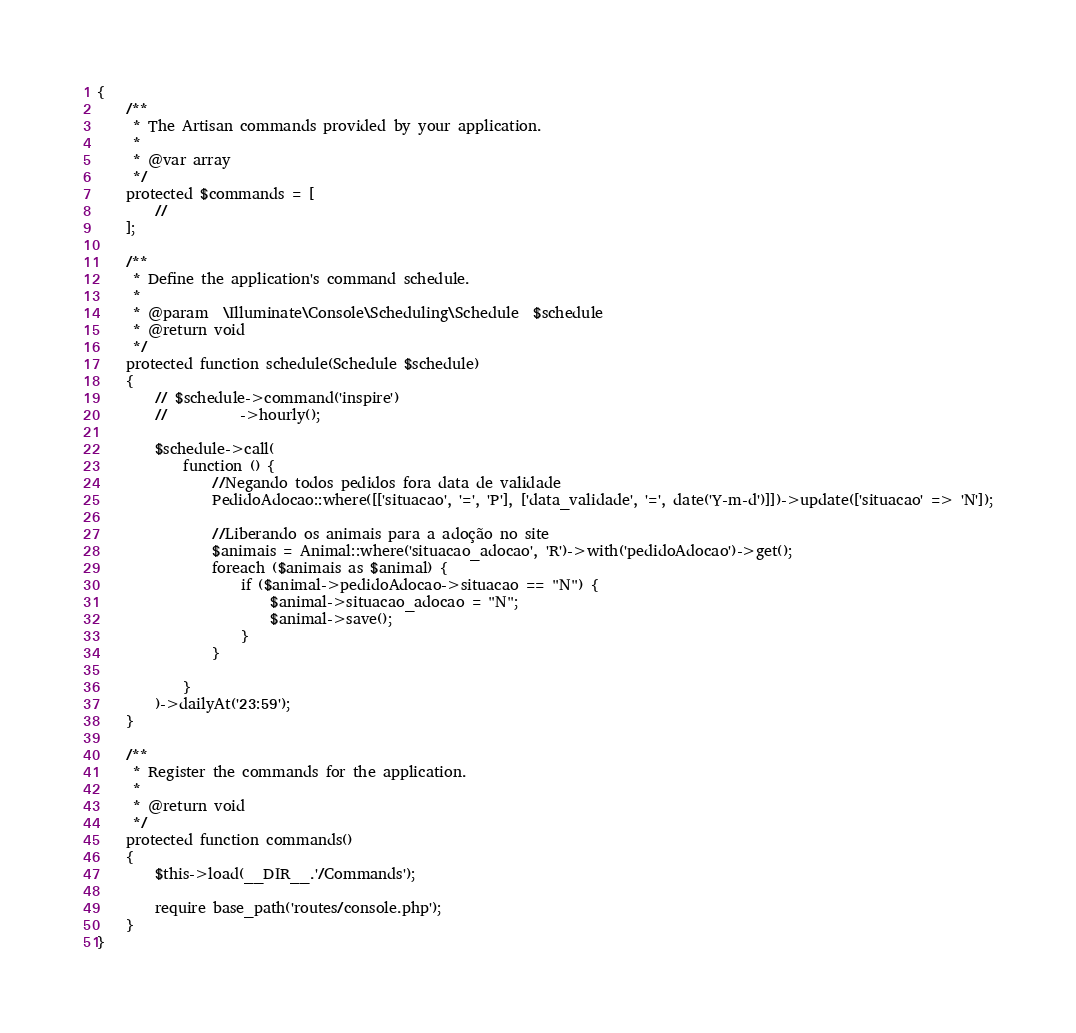Convert code to text. <code><loc_0><loc_0><loc_500><loc_500><_PHP_>{
    /**
     * The Artisan commands provided by your application.
     *
     * @var array
     */
    protected $commands = [
        //
    ];

    /**
     * Define the application's command schedule.
     *
     * @param  \Illuminate\Console\Scheduling\Schedule  $schedule
     * @return void
     */
    protected function schedule(Schedule $schedule)
    {
        // $schedule->command('inspire')
        //          ->hourly();

        $schedule->call(
            function () {
                //Negando todos pedidos fora data de validade            
                PedidoAdocao::where([['situacao', '=', 'P'], ['data_validade', '=', date('Y-m-d')]])->update(['situacao' => 'N']);

                //Liberando os animais para a adoção no site
                $animais = Animal::where('situacao_adocao', 'R')->with('pedidoAdocao')->get();
                foreach ($animais as $animal) {
                    if ($animal->pedidoAdocao->situacao == "N") {
                        $animal->situacao_adocao = "N";
                        $animal->save();
                    }
                }

            }
        )->dailyAt('23:59');   
    }

    /**
     * Register the commands for the application.
     *
     * @return void
     */
    protected function commands()
    {
        $this->load(__DIR__.'/Commands');

        require base_path('routes/console.php');
    }
}
</code> 